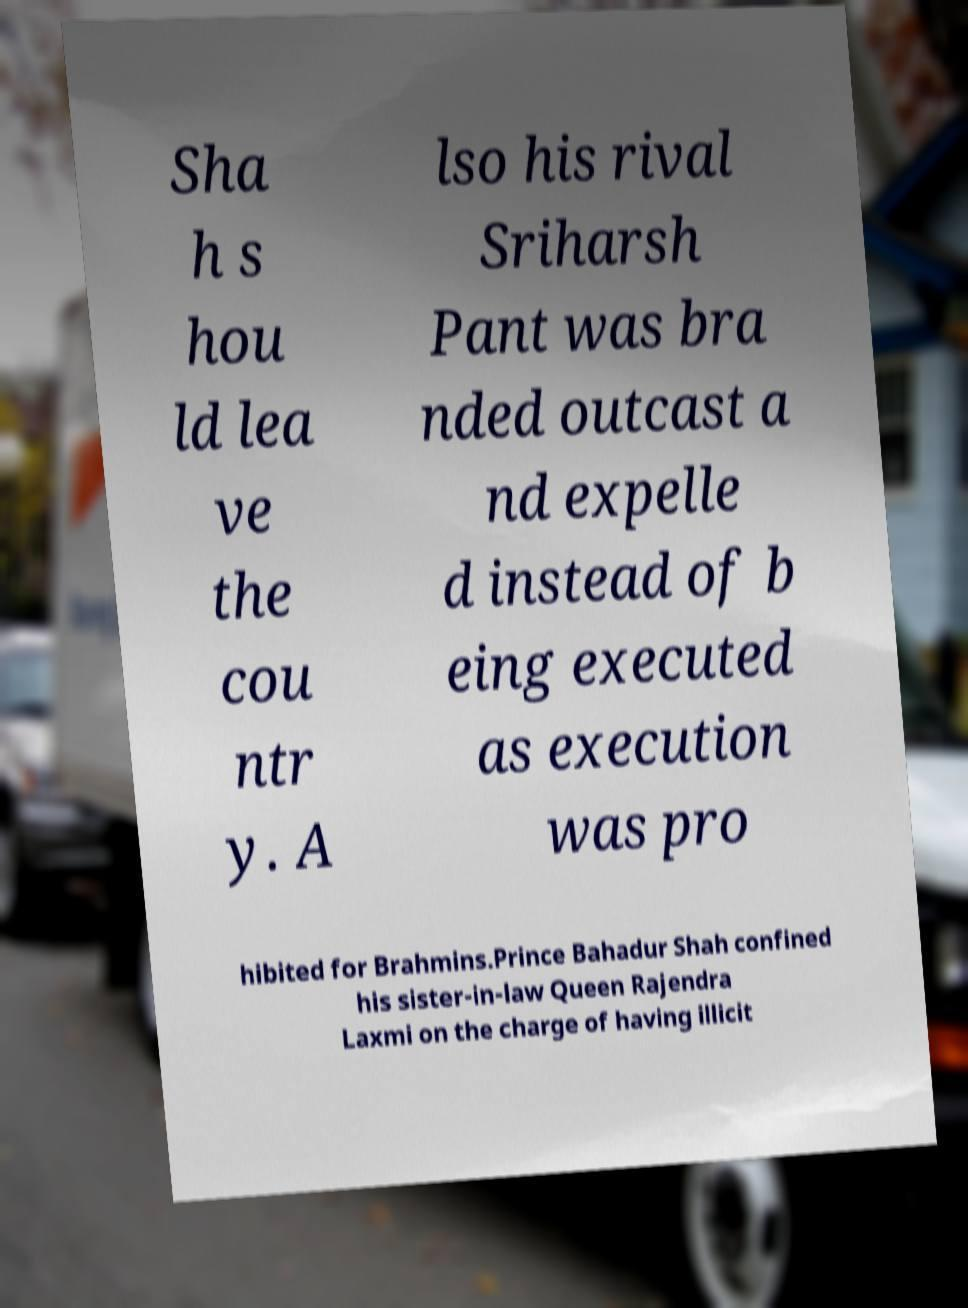For documentation purposes, I need the text within this image transcribed. Could you provide that? Sha h s hou ld lea ve the cou ntr y. A lso his rival Sriharsh Pant was bra nded outcast a nd expelle d instead of b eing executed as execution was pro hibited for Brahmins.Prince Bahadur Shah confined his sister-in-law Queen Rajendra Laxmi on the charge of having illicit 